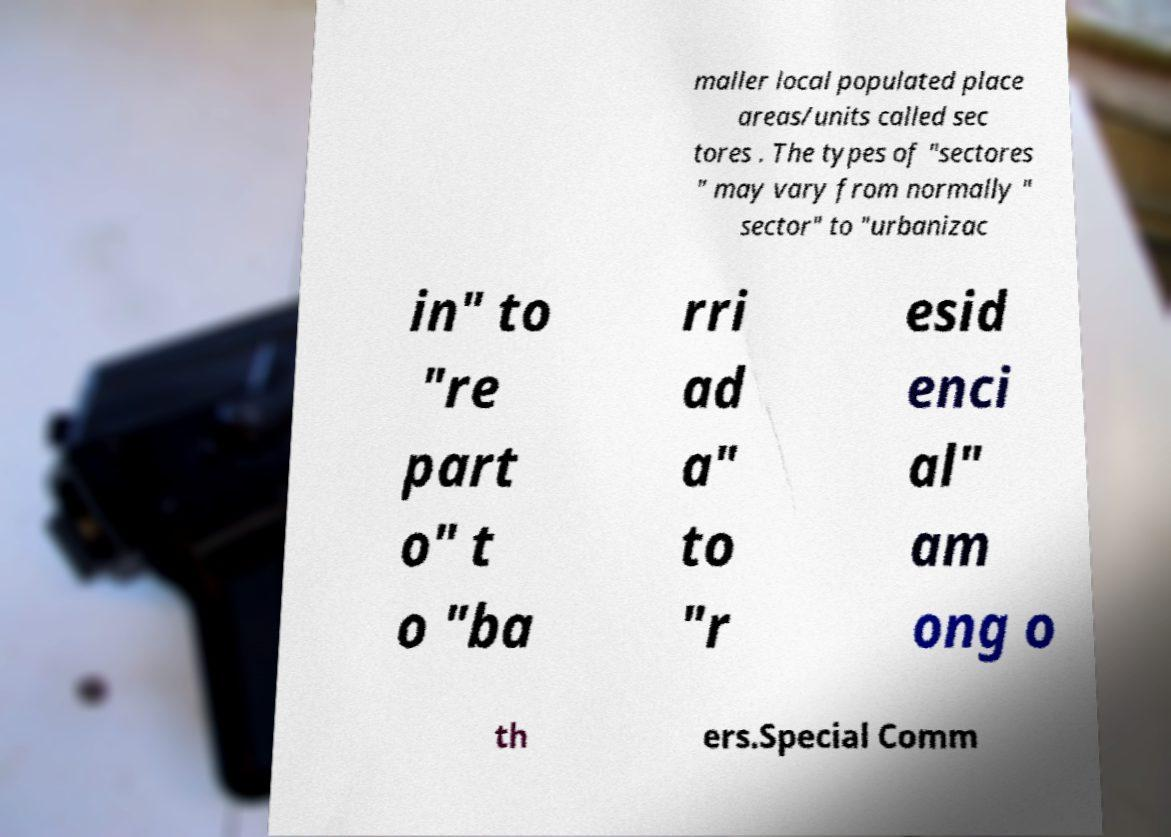Can you read and provide the text displayed in the image?This photo seems to have some interesting text. Can you extract and type it out for me? maller local populated place areas/units called sec tores . The types of "sectores " may vary from normally " sector" to "urbanizac in" to "re part o" t o "ba rri ad a" to "r esid enci al" am ong o th ers.Special Comm 